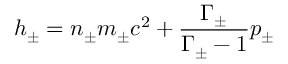Convert formula to latex. <formula><loc_0><loc_0><loc_500><loc_500>h _ { \pm } = n _ { \pm } m _ { \pm } c ^ { 2 } + \frac { \Gamma _ { \pm } } { \Gamma _ { \pm } - 1 } p _ { \pm }</formula> 